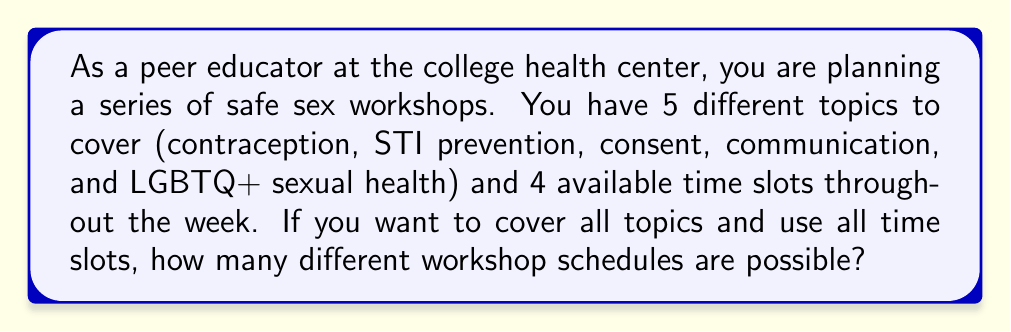Provide a solution to this math problem. Let's approach this step-by-step:

1) We have 5 topics and 4 time slots. This means we need to select 4 out of the 5 topics and arrange them in the 4 time slots.

2) This problem can be solved using the concept of permutations. Specifically, we need to calculate the number of permutations of 4 items chosen from 5 items.

3) The formula for this is:

   $$P(5,4) = \frac{5!}{(5-4)!} = \frac{5!}{1!}$$

4) Let's expand this:
   $$\frac{5 * 4 * 3 * 2 * 1}{1} = 120$$

5) This result gives us the number of ways to arrange 4 topics out of 5 in the 4 time slots.

6) However, we need to consider that the 5th topic (the one not chosen for the 4 slots) can be any of the 5 topics. This multiplies our possibilities by 5.

7) Therefore, the total number of possible schedules is:

   $$120 * 5 = 600$$

Thus, there are 600 different possible workshop schedules.
Answer: 600 possible workshop schedules 